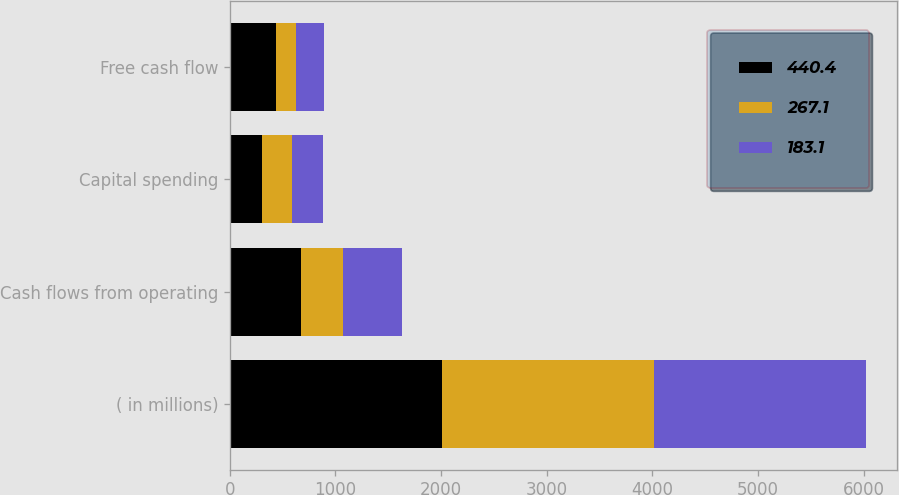Convert chart to OTSL. <chart><loc_0><loc_0><loc_500><loc_500><stacked_bar_chart><ecel><fcel>( in millions)<fcel>Cash flows from operating<fcel>Capital spending<fcel>Free cash flow<nl><fcel>440.4<fcel>2007<fcel>673<fcel>308.5<fcel>440.4<nl><fcel>267.1<fcel>2006<fcel>401.4<fcel>279.6<fcel>183.1<nl><fcel>183.1<fcel>2005<fcel>558.8<fcel>291.7<fcel>267.1<nl></chart> 